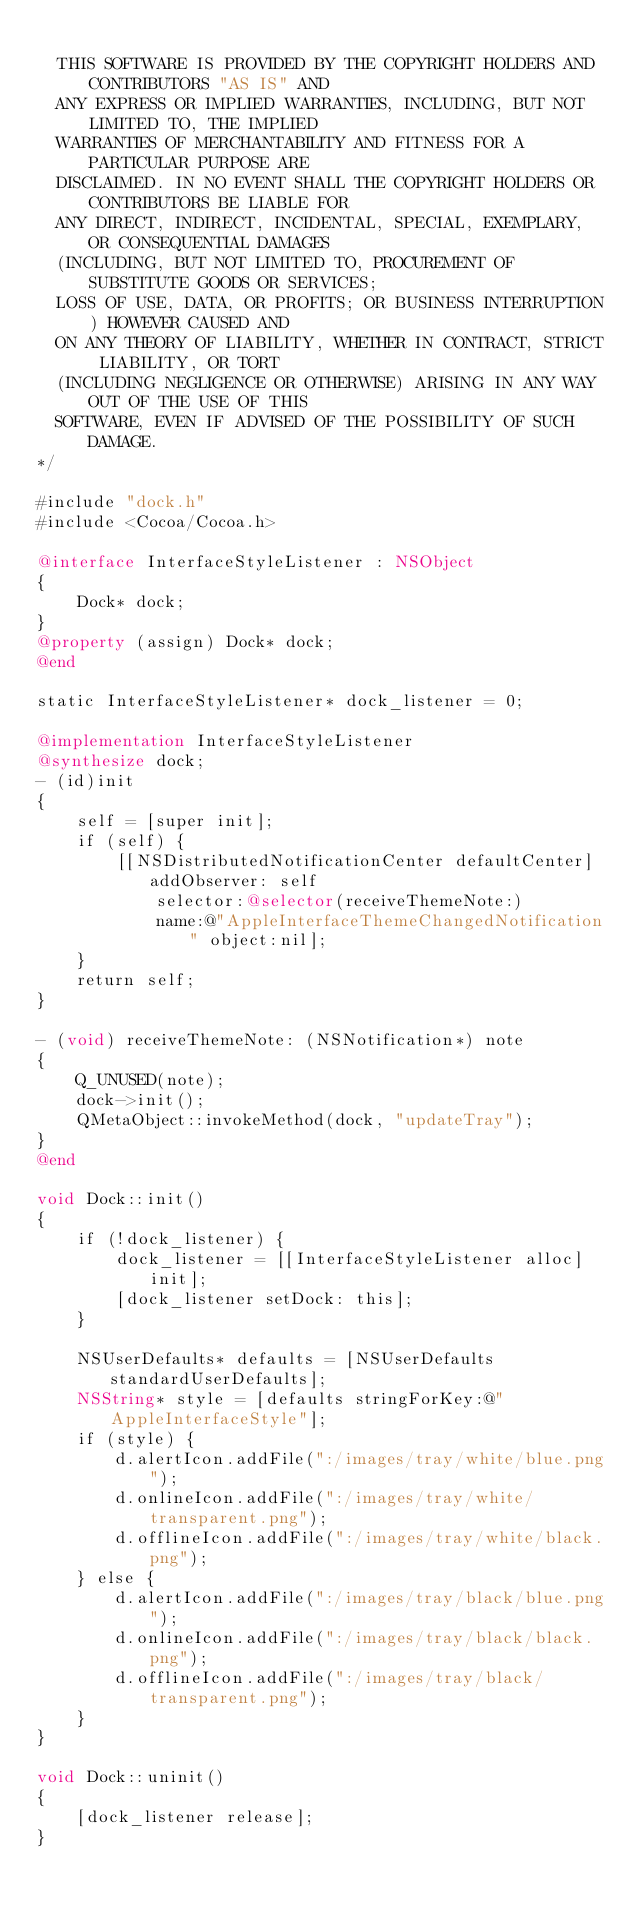Convert code to text. <code><loc_0><loc_0><loc_500><loc_500><_ObjectiveC_>
  THIS SOFTWARE IS PROVIDED BY THE COPYRIGHT HOLDERS AND CONTRIBUTORS "AS IS" AND
  ANY EXPRESS OR IMPLIED WARRANTIES, INCLUDING, BUT NOT LIMITED TO, THE IMPLIED
  WARRANTIES OF MERCHANTABILITY AND FITNESS FOR A PARTICULAR PURPOSE ARE
  DISCLAIMED. IN NO EVENT SHALL THE COPYRIGHT HOLDERS OR CONTRIBUTORS BE LIABLE FOR
  ANY DIRECT, INDIRECT, INCIDENTAL, SPECIAL, EXEMPLARY, OR CONSEQUENTIAL DAMAGES
  (INCLUDING, BUT NOT LIMITED TO, PROCUREMENT OF SUBSTITUTE GOODS OR SERVICES;
  LOSS OF USE, DATA, OR PROFITS; OR BUSINESS INTERRUPTION) HOWEVER CAUSED AND
  ON ANY THEORY OF LIABILITY, WHETHER IN CONTRACT, STRICT LIABILITY, OR TORT
  (INCLUDING NEGLIGENCE OR OTHERWISE) ARISING IN ANY WAY OUT OF THE USE OF THIS
  SOFTWARE, EVEN IF ADVISED OF THE POSSIBILITY OF SUCH DAMAGE.
*/

#include "dock.h"
#include <Cocoa/Cocoa.h>

@interface InterfaceStyleListener : NSObject
{
    Dock* dock;
}
@property (assign) Dock* dock;
@end

static InterfaceStyleListener* dock_listener = 0;

@implementation InterfaceStyleListener
@synthesize dock;
- (id)init
{
    self = [super init];
    if (self) {
        [[NSDistributedNotificationCenter defaultCenter] addObserver: self
            selector:@selector(receiveThemeNote:)
            name:@"AppleInterfaceThemeChangedNotification" object:nil];
    }
    return self;
}

- (void) receiveThemeNote: (NSNotification*) note
{
    Q_UNUSED(note);
    dock->init();
    QMetaObject::invokeMethod(dock, "updateTray");
}
@end

void Dock::init()
{
    if (!dock_listener) {
        dock_listener = [[InterfaceStyleListener alloc] init];
        [dock_listener setDock: this];
    }

    NSUserDefaults* defaults = [NSUserDefaults standardUserDefaults];
    NSString* style = [defaults stringForKey:@"AppleInterfaceStyle"];
    if (style) {
        d.alertIcon.addFile(":/images/tray/white/blue.png");
        d.onlineIcon.addFile(":/images/tray/white/transparent.png");
        d.offlineIcon.addFile(":/images/tray/white/black.png");
    } else {
        d.alertIcon.addFile(":/images/tray/black/blue.png");
        d.onlineIcon.addFile(":/images/tray/black/black.png");
        d.offlineIcon.addFile(":/images/tray/black/transparent.png");
    }
}

void Dock::uninit()
{
    [dock_listener release];
}
</code> 